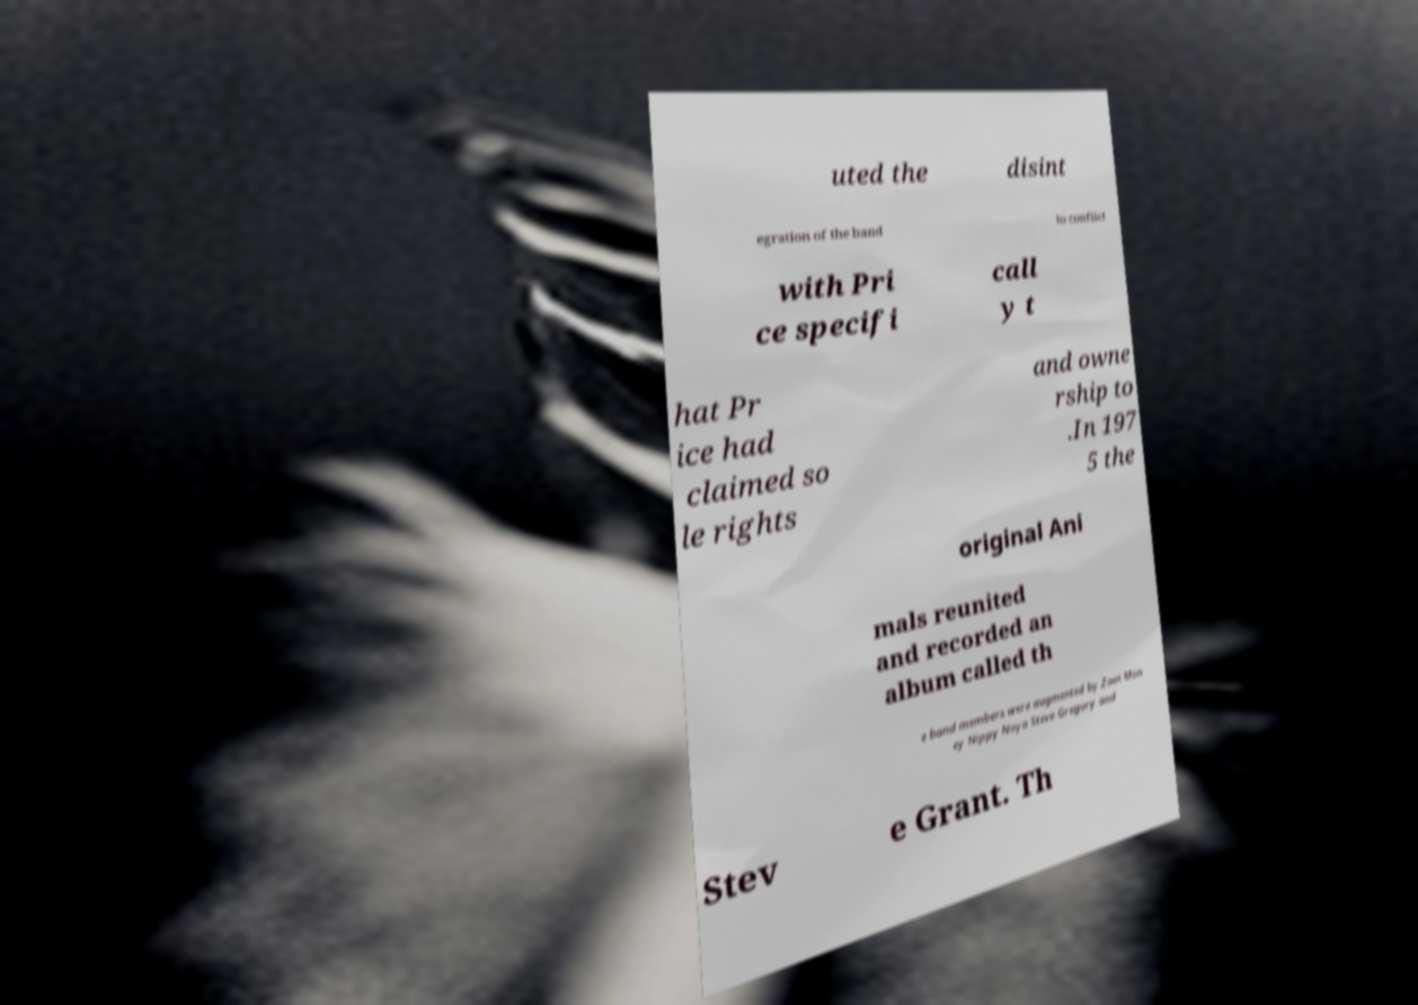There's text embedded in this image that I need extracted. Can you transcribe it verbatim? uted the disint egration of the band to conflict with Pri ce specifi call y t hat Pr ice had claimed so le rights and owne rship to .In 197 5 the original Ani mals reunited and recorded an album called th e band members were augmented by Zoot Mon ey Nippy Noya Steve Gregory and Stev e Grant. Th 